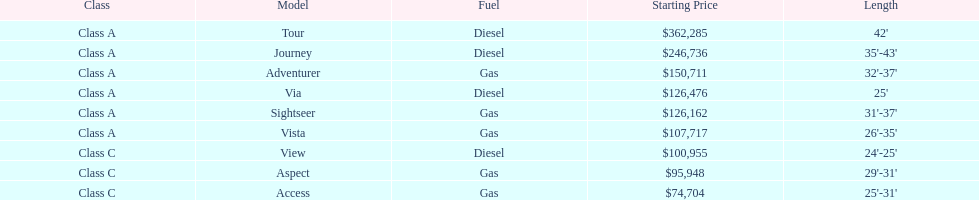How many models are available in lengths longer than 30 feet? 7. 